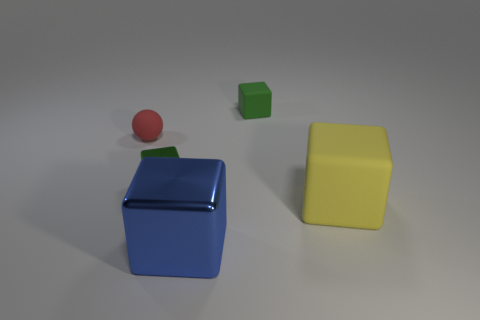What number of metallic things are either green things or balls?
Provide a succinct answer. 1. Is there a gray thing made of the same material as the small red thing?
Offer a very short reply. No. What number of things are either things behind the big yellow block or blocks in front of the yellow thing?
Offer a very short reply. 4. Do the tiny matte object that is right of the large shiny thing and the ball have the same color?
Your answer should be very brief. No. What number of other objects are the same color as the matte sphere?
Provide a short and direct response. 0. What is the material of the small sphere?
Offer a very short reply. Rubber. There is a rubber thing left of the green rubber thing; is its size the same as the yellow matte cube?
Give a very brief answer. No. Is there any other thing that has the same size as the yellow object?
Your response must be concise. Yes. The other shiny object that is the same shape as the big blue metal object is what size?
Ensure brevity in your answer.  Small. Are there the same number of yellow blocks to the left of the large rubber thing and metallic objects that are on the right side of the large shiny object?
Offer a terse response. Yes. 